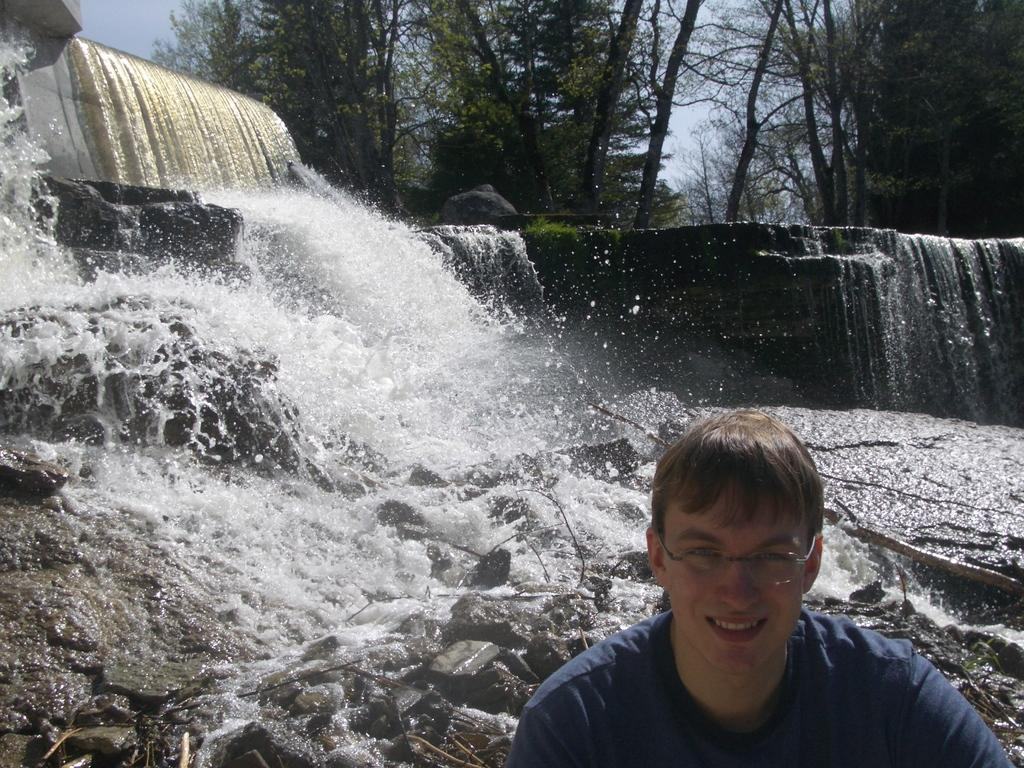What is the person in the image wearing? The person is wearing specs in the image. What is the person's facial expression? The person is smiling in the image. What natural feature can be seen in the image? There is a waterfall on rocks in the image. What type of vegetation is visible in the background? There are trees in the background of the image. What part of the natural environment is visible in the background? The sky is visible in the background of the image. What type of stretch is the monkey doing in the image? There is no monkey present in the image, so it is not possible to answer that question. 